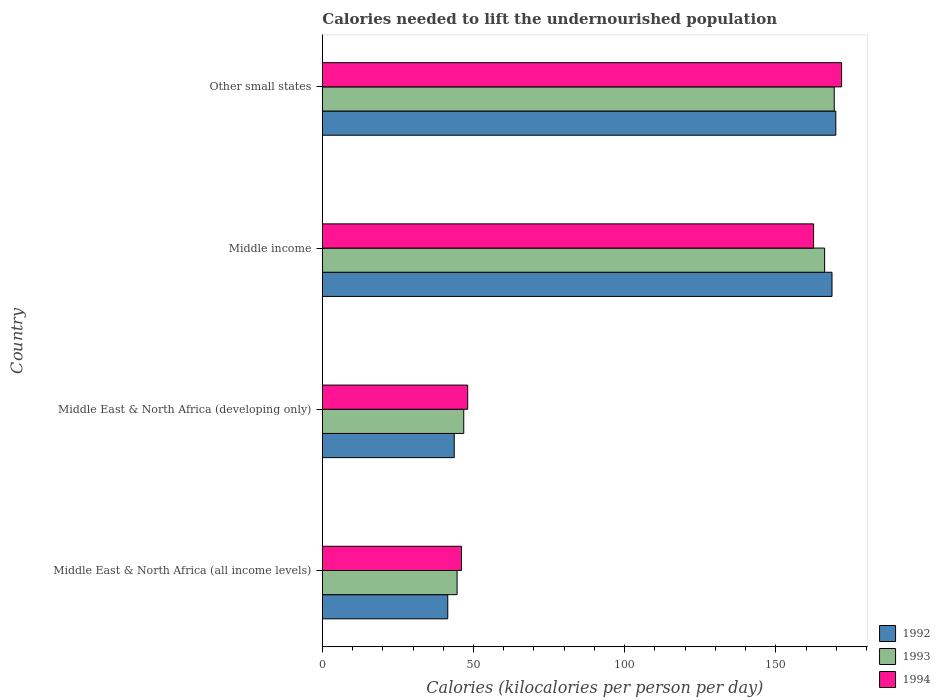What is the label of the 4th group of bars from the top?
Offer a very short reply. Middle East & North Africa (all income levels). In how many cases, is the number of bars for a given country not equal to the number of legend labels?
Give a very brief answer. 0. What is the total calories needed to lift the undernourished population in 1993 in Middle income?
Offer a very short reply. 166.16. Across all countries, what is the maximum total calories needed to lift the undernourished population in 1994?
Ensure brevity in your answer.  171.77. Across all countries, what is the minimum total calories needed to lift the undernourished population in 1994?
Your answer should be compact. 46.03. In which country was the total calories needed to lift the undernourished population in 1992 maximum?
Keep it short and to the point. Other small states. In which country was the total calories needed to lift the undernourished population in 1994 minimum?
Ensure brevity in your answer.  Middle East & North Africa (all income levels). What is the total total calories needed to lift the undernourished population in 1993 in the graph?
Give a very brief answer. 426.86. What is the difference between the total calories needed to lift the undernourished population in 1993 in Middle income and that in Other small states?
Your answer should be compact. -3.18. What is the difference between the total calories needed to lift the undernourished population in 1994 in Middle income and the total calories needed to lift the undernourished population in 1993 in Middle East & North Africa (all income levels)?
Offer a very short reply. 117.93. What is the average total calories needed to lift the undernourished population in 1994 per country?
Ensure brevity in your answer.  107.09. What is the difference between the total calories needed to lift the undernourished population in 1992 and total calories needed to lift the undernourished population in 1994 in Middle income?
Ensure brevity in your answer.  6.09. In how many countries, is the total calories needed to lift the undernourished population in 1993 greater than 130 kilocalories?
Give a very brief answer. 2. What is the ratio of the total calories needed to lift the undernourished population in 1992 in Middle East & North Africa (developing only) to that in Other small states?
Offer a terse response. 0.26. Is the total calories needed to lift the undernourished population in 1994 in Middle East & North Africa (all income levels) less than that in Other small states?
Make the answer very short. Yes. Is the difference between the total calories needed to lift the undernourished population in 1992 in Middle East & North Africa (all income levels) and Other small states greater than the difference between the total calories needed to lift the undernourished population in 1994 in Middle East & North Africa (all income levels) and Other small states?
Your response must be concise. No. What is the difference between the highest and the second highest total calories needed to lift the undernourished population in 1992?
Offer a very short reply. 1.26. What is the difference between the highest and the lowest total calories needed to lift the undernourished population in 1994?
Your answer should be very brief. 125.74. What does the 2nd bar from the top in Middle East & North Africa (all income levels) represents?
Give a very brief answer. 1993. What does the 1st bar from the bottom in Other small states represents?
Keep it short and to the point. 1992. How are the legend labels stacked?
Your response must be concise. Vertical. What is the title of the graph?
Offer a terse response. Calories needed to lift the undernourished population. Does "1969" appear as one of the legend labels in the graph?
Ensure brevity in your answer.  No. What is the label or title of the X-axis?
Ensure brevity in your answer.  Calories (kilocalories per person per day). What is the label or title of the Y-axis?
Give a very brief answer. Country. What is the Calories (kilocalories per person per day) of 1992 in Middle East & North Africa (all income levels)?
Ensure brevity in your answer.  41.5. What is the Calories (kilocalories per person per day) of 1993 in Middle East & North Africa (all income levels)?
Your answer should be very brief. 44.58. What is the Calories (kilocalories per person per day) of 1994 in Middle East & North Africa (all income levels)?
Your response must be concise. 46.03. What is the Calories (kilocalories per person per day) of 1992 in Middle East & North Africa (developing only)?
Give a very brief answer. 43.63. What is the Calories (kilocalories per person per day) of 1993 in Middle East & North Africa (developing only)?
Your answer should be compact. 46.78. What is the Calories (kilocalories per person per day) of 1994 in Middle East & North Africa (developing only)?
Keep it short and to the point. 48.08. What is the Calories (kilocalories per person per day) in 1992 in Middle income?
Give a very brief answer. 168.6. What is the Calories (kilocalories per person per day) of 1993 in Middle income?
Your answer should be very brief. 166.16. What is the Calories (kilocalories per person per day) in 1994 in Middle income?
Keep it short and to the point. 162.51. What is the Calories (kilocalories per person per day) of 1992 in Other small states?
Provide a succinct answer. 169.86. What is the Calories (kilocalories per person per day) in 1993 in Other small states?
Offer a very short reply. 169.34. What is the Calories (kilocalories per person per day) of 1994 in Other small states?
Your answer should be compact. 171.77. Across all countries, what is the maximum Calories (kilocalories per person per day) of 1992?
Ensure brevity in your answer.  169.86. Across all countries, what is the maximum Calories (kilocalories per person per day) in 1993?
Keep it short and to the point. 169.34. Across all countries, what is the maximum Calories (kilocalories per person per day) in 1994?
Provide a succinct answer. 171.77. Across all countries, what is the minimum Calories (kilocalories per person per day) of 1992?
Your response must be concise. 41.5. Across all countries, what is the minimum Calories (kilocalories per person per day) of 1993?
Your answer should be compact. 44.58. Across all countries, what is the minimum Calories (kilocalories per person per day) in 1994?
Make the answer very short. 46.03. What is the total Calories (kilocalories per person per day) of 1992 in the graph?
Make the answer very short. 423.58. What is the total Calories (kilocalories per person per day) of 1993 in the graph?
Your response must be concise. 426.86. What is the total Calories (kilocalories per person per day) of 1994 in the graph?
Your response must be concise. 428.38. What is the difference between the Calories (kilocalories per person per day) in 1992 in Middle East & North Africa (all income levels) and that in Middle East & North Africa (developing only)?
Offer a very short reply. -2.13. What is the difference between the Calories (kilocalories per person per day) of 1993 in Middle East & North Africa (all income levels) and that in Middle East & North Africa (developing only)?
Offer a terse response. -2.2. What is the difference between the Calories (kilocalories per person per day) of 1994 in Middle East & North Africa (all income levels) and that in Middle East & North Africa (developing only)?
Your response must be concise. -2.05. What is the difference between the Calories (kilocalories per person per day) of 1992 in Middle East & North Africa (all income levels) and that in Middle income?
Offer a terse response. -127.1. What is the difference between the Calories (kilocalories per person per day) of 1993 in Middle East & North Africa (all income levels) and that in Middle income?
Offer a very short reply. -121.58. What is the difference between the Calories (kilocalories per person per day) of 1994 in Middle East & North Africa (all income levels) and that in Middle income?
Your answer should be compact. -116.48. What is the difference between the Calories (kilocalories per person per day) of 1992 in Middle East & North Africa (all income levels) and that in Other small states?
Ensure brevity in your answer.  -128.36. What is the difference between the Calories (kilocalories per person per day) in 1993 in Middle East & North Africa (all income levels) and that in Other small states?
Keep it short and to the point. -124.76. What is the difference between the Calories (kilocalories per person per day) of 1994 in Middle East & North Africa (all income levels) and that in Other small states?
Ensure brevity in your answer.  -125.74. What is the difference between the Calories (kilocalories per person per day) of 1992 in Middle East & North Africa (developing only) and that in Middle income?
Keep it short and to the point. -124.97. What is the difference between the Calories (kilocalories per person per day) of 1993 in Middle East & North Africa (developing only) and that in Middle income?
Ensure brevity in your answer.  -119.37. What is the difference between the Calories (kilocalories per person per day) of 1994 in Middle East & North Africa (developing only) and that in Middle income?
Offer a very short reply. -114.43. What is the difference between the Calories (kilocalories per person per day) of 1992 in Middle East & North Africa (developing only) and that in Other small states?
Your answer should be compact. -126.23. What is the difference between the Calories (kilocalories per person per day) in 1993 in Middle East & North Africa (developing only) and that in Other small states?
Offer a very short reply. -122.56. What is the difference between the Calories (kilocalories per person per day) in 1994 in Middle East & North Africa (developing only) and that in Other small states?
Offer a terse response. -123.69. What is the difference between the Calories (kilocalories per person per day) of 1992 in Middle income and that in Other small states?
Your answer should be compact. -1.26. What is the difference between the Calories (kilocalories per person per day) of 1993 in Middle income and that in Other small states?
Your response must be concise. -3.18. What is the difference between the Calories (kilocalories per person per day) in 1994 in Middle income and that in Other small states?
Your answer should be very brief. -9.26. What is the difference between the Calories (kilocalories per person per day) in 1992 in Middle East & North Africa (all income levels) and the Calories (kilocalories per person per day) in 1993 in Middle East & North Africa (developing only)?
Your answer should be compact. -5.29. What is the difference between the Calories (kilocalories per person per day) in 1992 in Middle East & North Africa (all income levels) and the Calories (kilocalories per person per day) in 1994 in Middle East & North Africa (developing only)?
Your answer should be compact. -6.58. What is the difference between the Calories (kilocalories per person per day) of 1993 in Middle East & North Africa (all income levels) and the Calories (kilocalories per person per day) of 1994 in Middle East & North Africa (developing only)?
Make the answer very short. -3.5. What is the difference between the Calories (kilocalories per person per day) in 1992 in Middle East & North Africa (all income levels) and the Calories (kilocalories per person per day) in 1993 in Middle income?
Your answer should be compact. -124.66. What is the difference between the Calories (kilocalories per person per day) of 1992 in Middle East & North Africa (all income levels) and the Calories (kilocalories per person per day) of 1994 in Middle income?
Offer a very short reply. -121.01. What is the difference between the Calories (kilocalories per person per day) in 1993 in Middle East & North Africa (all income levels) and the Calories (kilocalories per person per day) in 1994 in Middle income?
Provide a short and direct response. -117.93. What is the difference between the Calories (kilocalories per person per day) of 1992 in Middle East & North Africa (all income levels) and the Calories (kilocalories per person per day) of 1993 in Other small states?
Provide a short and direct response. -127.84. What is the difference between the Calories (kilocalories per person per day) in 1992 in Middle East & North Africa (all income levels) and the Calories (kilocalories per person per day) in 1994 in Other small states?
Provide a short and direct response. -130.27. What is the difference between the Calories (kilocalories per person per day) in 1993 in Middle East & North Africa (all income levels) and the Calories (kilocalories per person per day) in 1994 in Other small states?
Keep it short and to the point. -127.19. What is the difference between the Calories (kilocalories per person per day) in 1992 in Middle East & North Africa (developing only) and the Calories (kilocalories per person per day) in 1993 in Middle income?
Your response must be concise. -122.52. What is the difference between the Calories (kilocalories per person per day) of 1992 in Middle East & North Africa (developing only) and the Calories (kilocalories per person per day) of 1994 in Middle income?
Your answer should be compact. -118.87. What is the difference between the Calories (kilocalories per person per day) of 1993 in Middle East & North Africa (developing only) and the Calories (kilocalories per person per day) of 1994 in Middle income?
Make the answer very short. -115.72. What is the difference between the Calories (kilocalories per person per day) in 1992 in Middle East & North Africa (developing only) and the Calories (kilocalories per person per day) in 1993 in Other small states?
Provide a succinct answer. -125.71. What is the difference between the Calories (kilocalories per person per day) of 1992 in Middle East & North Africa (developing only) and the Calories (kilocalories per person per day) of 1994 in Other small states?
Make the answer very short. -128.14. What is the difference between the Calories (kilocalories per person per day) in 1993 in Middle East & North Africa (developing only) and the Calories (kilocalories per person per day) in 1994 in Other small states?
Ensure brevity in your answer.  -124.99. What is the difference between the Calories (kilocalories per person per day) in 1992 in Middle income and the Calories (kilocalories per person per day) in 1993 in Other small states?
Provide a short and direct response. -0.74. What is the difference between the Calories (kilocalories per person per day) of 1992 in Middle income and the Calories (kilocalories per person per day) of 1994 in Other small states?
Offer a terse response. -3.17. What is the difference between the Calories (kilocalories per person per day) of 1993 in Middle income and the Calories (kilocalories per person per day) of 1994 in Other small states?
Make the answer very short. -5.61. What is the average Calories (kilocalories per person per day) of 1992 per country?
Offer a very short reply. 105.9. What is the average Calories (kilocalories per person per day) of 1993 per country?
Keep it short and to the point. 106.71. What is the average Calories (kilocalories per person per day) in 1994 per country?
Provide a succinct answer. 107.09. What is the difference between the Calories (kilocalories per person per day) in 1992 and Calories (kilocalories per person per day) in 1993 in Middle East & North Africa (all income levels)?
Make the answer very short. -3.08. What is the difference between the Calories (kilocalories per person per day) in 1992 and Calories (kilocalories per person per day) in 1994 in Middle East & North Africa (all income levels)?
Offer a very short reply. -4.53. What is the difference between the Calories (kilocalories per person per day) of 1993 and Calories (kilocalories per person per day) of 1994 in Middle East & North Africa (all income levels)?
Your answer should be compact. -1.45. What is the difference between the Calories (kilocalories per person per day) of 1992 and Calories (kilocalories per person per day) of 1993 in Middle East & North Africa (developing only)?
Make the answer very short. -3.15. What is the difference between the Calories (kilocalories per person per day) of 1992 and Calories (kilocalories per person per day) of 1994 in Middle East & North Africa (developing only)?
Ensure brevity in your answer.  -4.45. What is the difference between the Calories (kilocalories per person per day) in 1993 and Calories (kilocalories per person per day) in 1994 in Middle East & North Africa (developing only)?
Keep it short and to the point. -1.29. What is the difference between the Calories (kilocalories per person per day) of 1992 and Calories (kilocalories per person per day) of 1993 in Middle income?
Your answer should be compact. 2.44. What is the difference between the Calories (kilocalories per person per day) of 1992 and Calories (kilocalories per person per day) of 1994 in Middle income?
Offer a terse response. 6.09. What is the difference between the Calories (kilocalories per person per day) in 1993 and Calories (kilocalories per person per day) in 1994 in Middle income?
Give a very brief answer. 3.65. What is the difference between the Calories (kilocalories per person per day) of 1992 and Calories (kilocalories per person per day) of 1993 in Other small states?
Offer a terse response. 0.52. What is the difference between the Calories (kilocalories per person per day) of 1992 and Calories (kilocalories per person per day) of 1994 in Other small states?
Provide a short and direct response. -1.91. What is the difference between the Calories (kilocalories per person per day) of 1993 and Calories (kilocalories per person per day) of 1994 in Other small states?
Your answer should be very brief. -2.43. What is the ratio of the Calories (kilocalories per person per day) in 1992 in Middle East & North Africa (all income levels) to that in Middle East & North Africa (developing only)?
Offer a very short reply. 0.95. What is the ratio of the Calories (kilocalories per person per day) in 1993 in Middle East & North Africa (all income levels) to that in Middle East & North Africa (developing only)?
Make the answer very short. 0.95. What is the ratio of the Calories (kilocalories per person per day) in 1994 in Middle East & North Africa (all income levels) to that in Middle East & North Africa (developing only)?
Your response must be concise. 0.96. What is the ratio of the Calories (kilocalories per person per day) of 1992 in Middle East & North Africa (all income levels) to that in Middle income?
Provide a short and direct response. 0.25. What is the ratio of the Calories (kilocalories per person per day) in 1993 in Middle East & North Africa (all income levels) to that in Middle income?
Give a very brief answer. 0.27. What is the ratio of the Calories (kilocalories per person per day) of 1994 in Middle East & North Africa (all income levels) to that in Middle income?
Keep it short and to the point. 0.28. What is the ratio of the Calories (kilocalories per person per day) of 1992 in Middle East & North Africa (all income levels) to that in Other small states?
Your answer should be very brief. 0.24. What is the ratio of the Calories (kilocalories per person per day) of 1993 in Middle East & North Africa (all income levels) to that in Other small states?
Your answer should be compact. 0.26. What is the ratio of the Calories (kilocalories per person per day) of 1994 in Middle East & North Africa (all income levels) to that in Other small states?
Your answer should be compact. 0.27. What is the ratio of the Calories (kilocalories per person per day) in 1992 in Middle East & North Africa (developing only) to that in Middle income?
Provide a succinct answer. 0.26. What is the ratio of the Calories (kilocalories per person per day) of 1993 in Middle East & North Africa (developing only) to that in Middle income?
Your response must be concise. 0.28. What is the ratio of the Calories (kilocalories per person per day) of 1994 in Middle East & North Africa (developing only) to that in Middle income?
Give a very brief answer. 0.3. What is the ratio of the Calories (kilocalories per person per day) in 1992 in Middle East & North Africa (developing only) to that in Other small states?
Your response must be concise. 0.26. What is the ratio of the Calories (kilocalories per person per day) of 1993 in Middle East & North Africa (developing only) to that in Other small states?
Offer a very short reply. 0.28. What is the ratio of the Calories (kilocalories per person per day) in 1994 in Middle East & North Africa (developing only) to that in Other small states?
Provide a succinct answer. 0.28. What is the ratio of the Calories (kilocalories per person per day) in 1993 in Middle income to that in Other small states?
Provide a succinct answer. 0.98. What is the ratio of the Calories (kilocalories per person per day) of 1994 in Middle income to that in Other small states?
Your response must be concise. 0.95. What is the difference between the highest and the second highest Calories (kilocalories per person per day) of 1992?
Provide a short and direct response. 1.26. What is the difference between the highest and the second highest Calories (kilocalories per person per day) in 1993?
Offer a terse response. 3.18. What is the difference between the highest and the second highest Calories (kilocalories per person per day) in 1994?
Provide a succinct answer. 9.26. What is the difference between the highest and the lowest Calories (kilocalories per person per day) in 1992?
Your answer should be compact. 128.36. What is the difference between the highest and the lowest Calories (kilocalories per person per day) in 1993?
Your answer should be compact. 124.76. What is the difference between the highest and the lowest Calories (kilocalories per person per day) of 1994?
Provide a succinct answer. 125.74. 